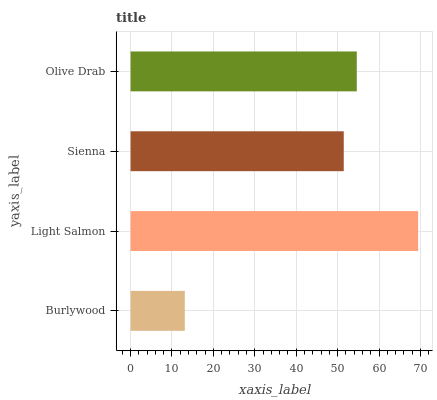Is Burlywood the minimum?
Answer yes or no. Yes. Is Light Salmon the maximum?
Answer yes or no. Yes. Is Sienna the minimum?
Answer yes or no. No. Is Sienna the maximum?
Answer yes or no. No. Is Light Salmon greater than Sienna?
Answer yes or no. Yes. Is Sienna less than Light Salmon?
Answer yes or no. Yes. Is Sienna greater than Light Salmon?
Answer yes or no. No. Is Light Salmon less than Sienna?
Answer yes or no. No. Is Olive Drab the high median?
Answer yes or no. Yes. Is Sienna the low median?
Answer yes or no. Yes. Is Sienna the high median?
Answer yes or no. No. Is Olive Drab the low median?
Answer yes or no. No. 